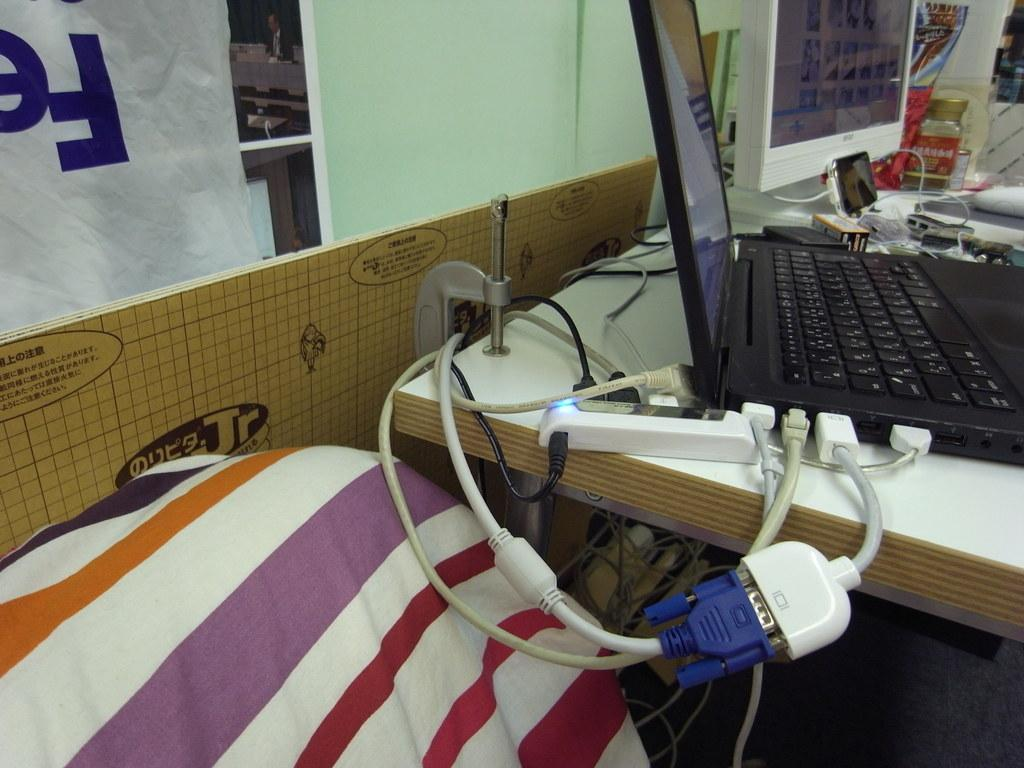What electronic device is visible in the image? There is a laptop in the image. What is connected to the laptop? There are wire connectors to the laptop. What can be seen on the table in the image? There are objects on the table. What is to the left of the image? There is a banner to the left of the image. What type of story is being told by the calendar in the image? There is no calendar present in the image, so it is not possible to determine what story might be told by a calendar. 